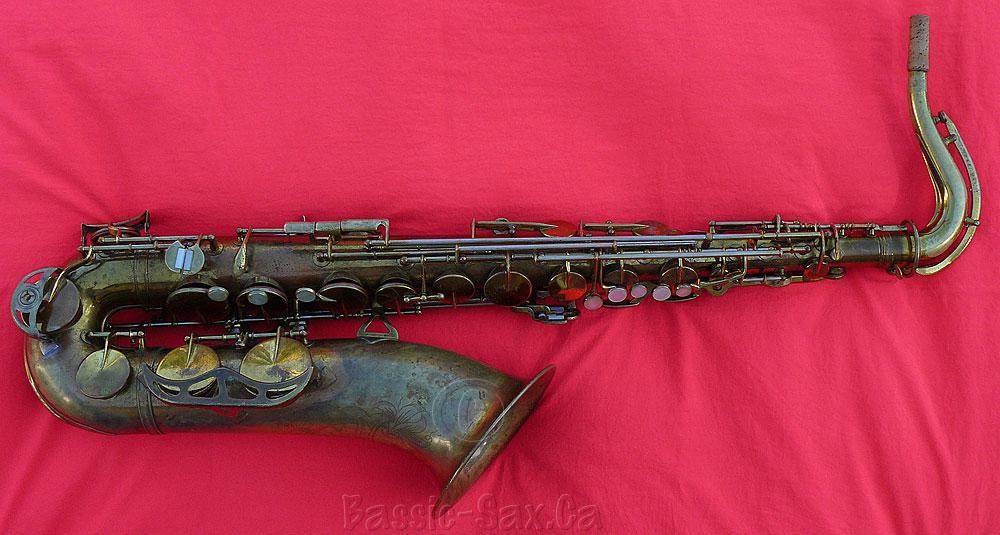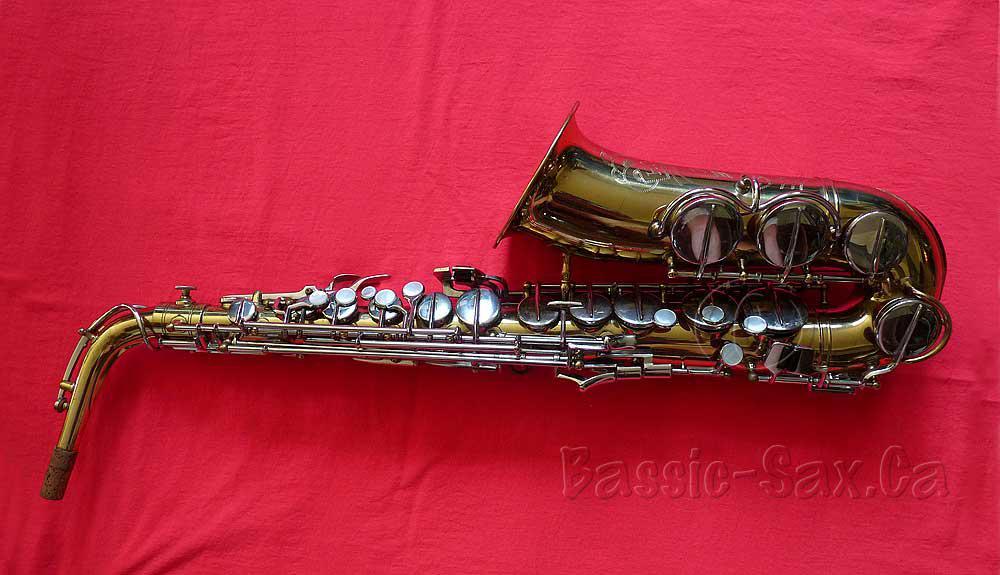The first image is the image on the left, the second image is the image on the right. Given the left and right images, does the statement "The saxophones are positioned in the same way on the red blanket." hold true? Answer yes or no. No. The first image is the image on the left, the second image is the image on the right. Examine the images to the left and right. Is the description "Saxophones displayed in the left and right images are positioned in the same way and facing same direction." accurate? Answer yes or no. No. 